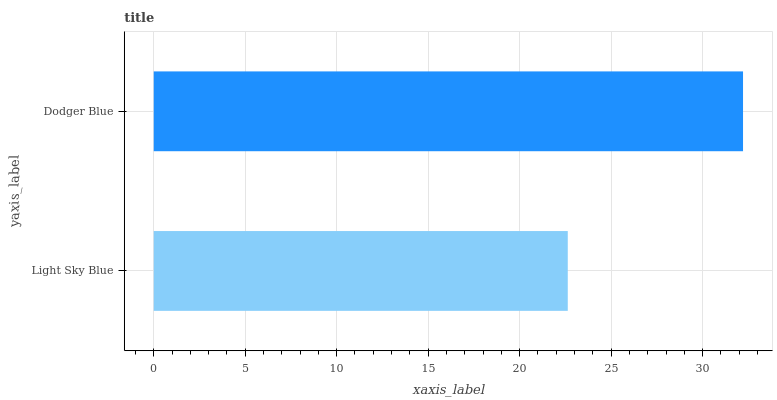Is Light Sky Blue the minimum?
Answer yes or no. Yes. Is Dodger Blue the maximum?
Answer yes or no. Yes. Is Dodger Blue the minimum?
Answer yes or no. No. Is Dodger Blue greater than Light Sky Blue?
Answer yes or no. Yes. Is Light Sky Blue less than Dodger Blue?
Answer yes or no. Yes. Is Light Sky Blue greater than Dodger Blue?
Answer yes or no. No. Is Dodger Blue less than Light Sky Blue?
Answer yes or no. No. Is Dodger Blue the high median?
Answer yes or no. Yes. Is Light Sky Blue the low median?
Answer yes or no. Yes. Is Light Sky Blue the high median?
Answer yes or no. No. Is Dodger Blue the low median?
Answer yes or no. No. 